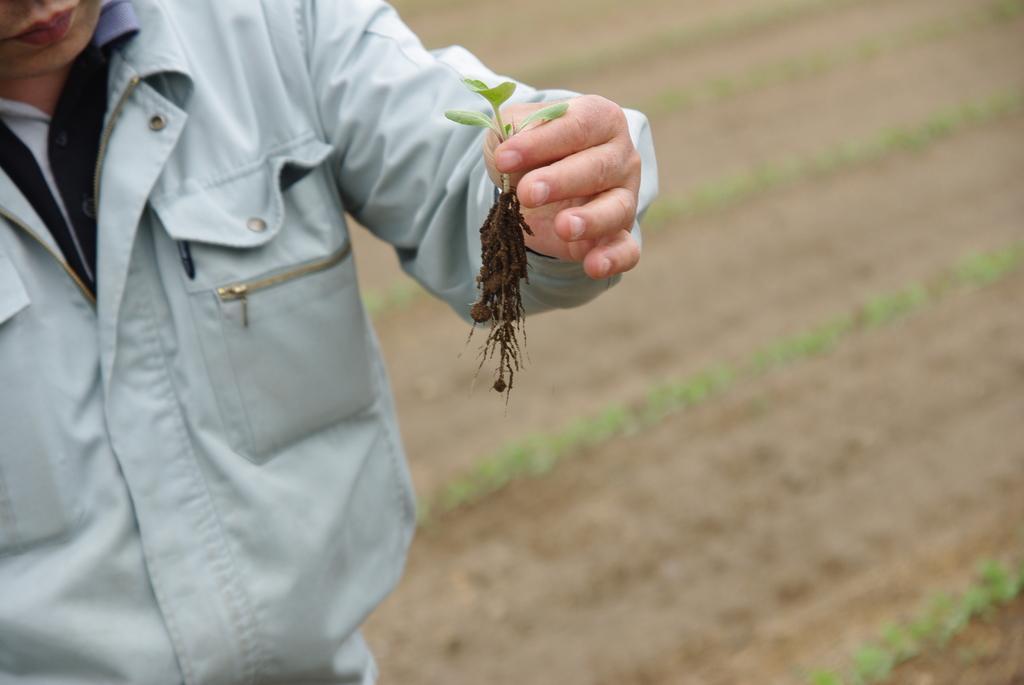Describe this image in one or two sentences. In this image we can see a person standing and holding a small plant. 